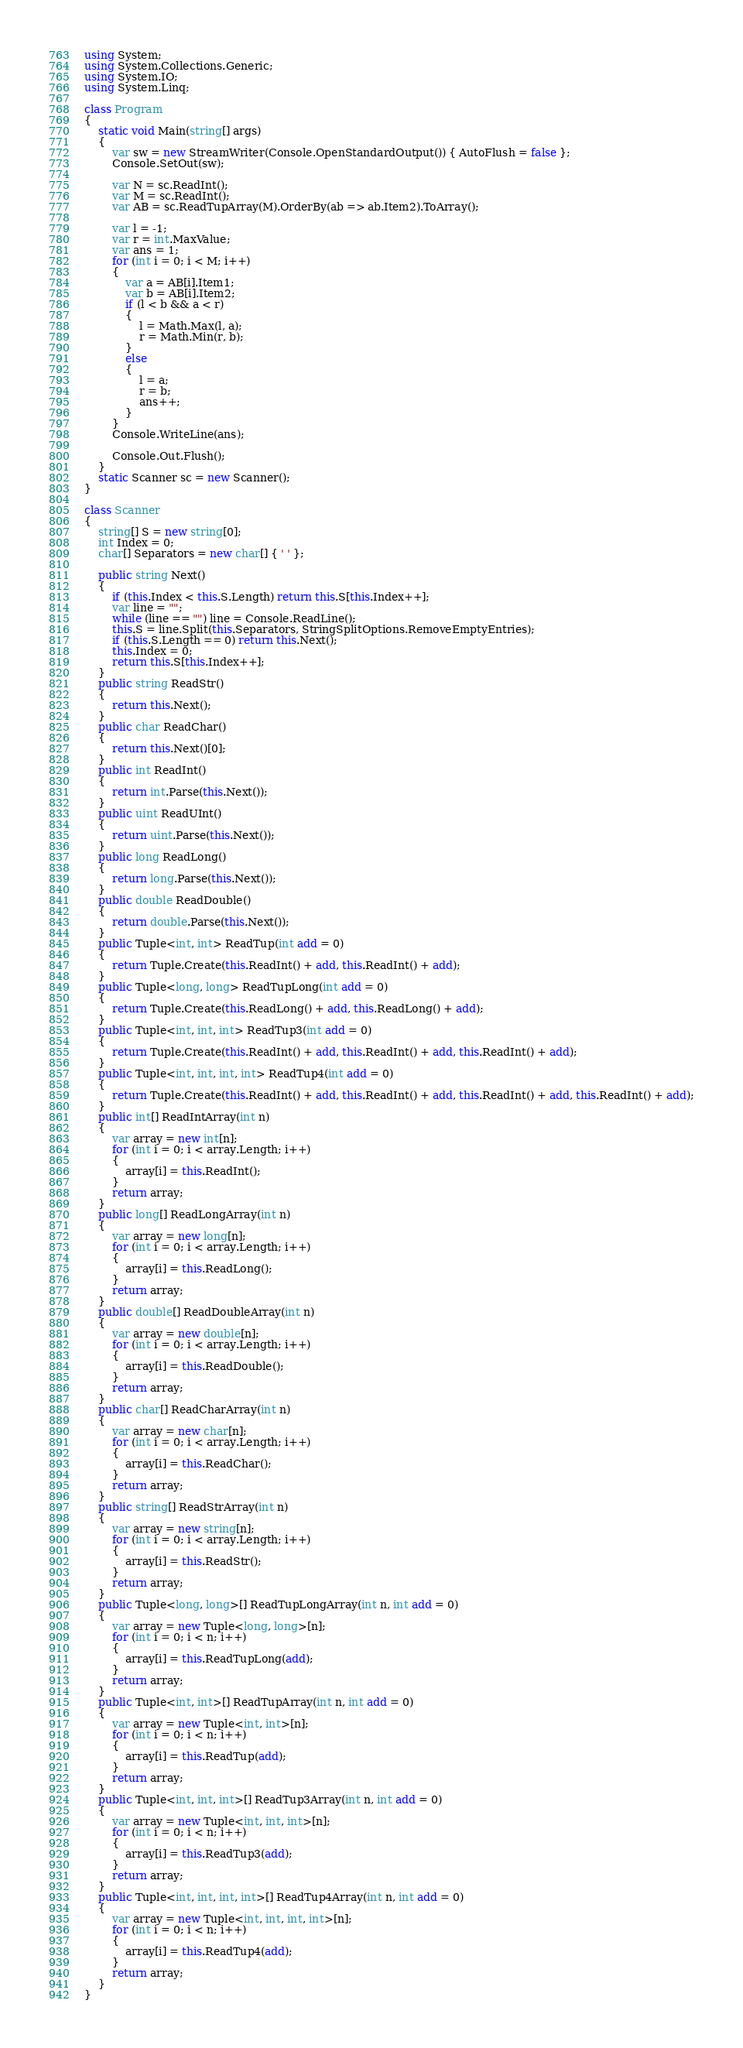Convert code to text. <code><loc_0><loc_0><loc_500><loc_500><_C#_>using System;
using System.Collections.Generic;
using System.IO;
using System.Linq;

class Program
{
    static void Main(string[] args)
    {
        var sw = new StreamWriter(Console.OpenStandardOutput()) { AutoFlush = false };
        Console.SetOut(sw);

        var N = sc.ReadInt();
        var M = sc.ReadInt();
        var AB = sc.ReadTupArray(M).OrderBy(ab => ab.Item2).ToArray();

        var l = -1;
        var r = int.MaxValue;
        var ans = 1;
        for (int i = 0; i < M; i++)
        {
            var a = AB[i].Item1;
            var b = AB[i].Item2;
            if (l < b && a < r)
            {
                l = Math.Max(l, a);
                r = Math.Min(r, b);
            }
            else
            {
                l = a;
                r = b;
                ans++;
            }
        }
        Console.WriteLine(ans);

        Console.Out.Flush();
    }
    static Scanner sc = new Scanner();
}

class Scanner
{
    string[] S = new string[0];
    int Index = 0;
    char[] Separators = new char[] { ' ' };

    public string Next()
    {
        if (this.Index < this.S.Length) return this.S[this.Index++];
        var line = "";
        while (line == "") line = Console.ReadLine();
        this.S = line.Split(this.Separators, StringSplitOptions.RemoveEmptyEntries);
        if (this.S.Length == 0) return this.Next();
        this.Index = 0;
        return this.S[this.Index++];
    }
    public string ReadStr()
    {
        return this.Next();
    }
    public char ReadChar()
    {
        return this.Next()[0];
    }
    public int ReadInt()
    {
        return int.Parse(this.Next());
    }
    public uint ReadUInt()
    {
        return uint.Parse(this.Next());
    }
    public long ReadLong()
    {
        return long.Parse(this.Next());
    }
    public double ReadDouble()
    {
        return double.Parse(this.Next());
    }
    public Tuple<int, int> ReadTup(int add = 0)
    {
        return Tuple.Create(this.ReadInt() + add, this.ReadInt() + add);
    }
    public Tuple<long, long> ReadTupLong(int add = 0)
    {
        return Tuple.Create(this.ReadLong() + add, this.ReadLong() + add);
    }
    public Tuple<int, int, int> ReadTup3(int add = 0)
    {
        return Tuple.Create(this.ReadInt() + add, this.ReadInt() + add, this.ReadInt() + add);
    }
    public Tuple<int, int, int, int> ReadTup4(int add = 0)
    {
        return Tuple.Create(this.ReadInt() + add, this.ReadInt() + add, this.ReadInt() + add, this.ReadInt() + add);
    }
    public int[] ReadIntArray(int n)
    {
        var array = new int[n];
        for (int i = 0; i < array.Length; i++)
        {
            array[i] = this.ReadInt();
        }
        return array;
    }
    public long[] ReadLongArray(int n)
    {
        var array = new long[n];
        for (int i = 0; i < array.Length; i++)
        {
            array[i] = this.ReadLong();
        }
        return array;
    }
    public double[] ReadDoubleArray(int n)
    {
        var array = new double[n];
        for (int i = 0; i < array.Length; i++)
        {
            array[i] = this.ReadDouble();
        }
        return array;
    }
    public char[] ReadCharArray(int n)
    {
        var array = new char[n];
        for (int i = 0; i < array.Length; i++)
        {
            array[i] = this.ReadChar();
        }
        return array;
    }
    public string[] ReadStrArray(int n)
    {
        var array = new string[n];
        for (int i = 0; i < array.Length; i++)
        {
            array[i] = this.ReadStr();
        }
        return array;
    }
    public Tuple<long, long>[] ReadTupLongArray(int n, int add = 0)
    {
        var array = new Tuple<long, long>[n];
        for (int i = 0; i < n; i++)
        {
            array[i] = this.ReadTupLong(add);
        }
        return array;
    }
    public Tuple<int, int>[] ReadTupArray(int n, int add = 0)
    {
        var array = new Tuple<int, int>[n];
        for (int i = 0; i < n; i++)
        {
            array[i] = this.ReadTup(add);
        }
        return array;
    }
    public Tuple<int, int, int>[] ReadTup3Array(int n, int add = 0)
    {
        var array = new Tuple<int, int, int>[n];
        for (int i = 0; i < n; i++)
        {
            array[i] = this.ReadTup3(add);
        }
        return array;
    }
    public Tuple<int, int, int, int>[] ReadTup4Array(int n, int add = 0)
    {
        var array = new Tuple<int, int, int, int>[n];
        for (int i = 0; i < n; i++)
        {
            array[i] = this.ReadTup4(add);
        }
        return array;
    }
}
</code> 